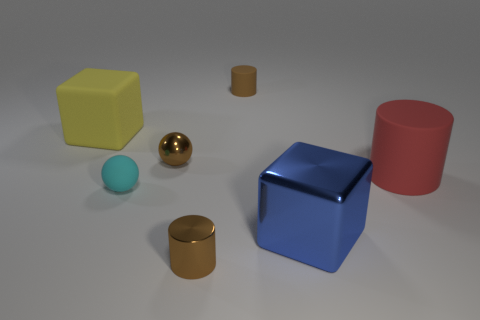Are there fewer red rubber cylinders to the left of the blue metallic thing than matte spheres that are left of the large red thing?
Give a very brief answer. Yes. How many big yellow blocks are there?
Your answer should be compact. 1. What material is the large red thing that is the same shape as the small brown rubber object?
Your answer should be very brief. Rubber. Is the number of red objects that are in front of the cyan thing less than the number of purple objects?
Provide a succinct answer. No. There is a matte thing that is behind the big yellow rubber cube; is it the same shape as the large yellow object?
Provide a short and direct response. No. Is there anything else that has the same color as the small rubber cylinder?
Ensure brevity in your answer.  Yes. There is a cube that is the same material as the big red cylinder; what is its size?
Offer a very short reply. Large. There is a tiny cylinder to the right of the brown shiny object that is to the right of the brown metal thing to the left of the brown shiny cylinder; what is it made of?
Your answer should be very brief. Rubber. Is the number of big blue things less than the number of purple things?
Give a very brief answer. No. Is the material of the large blue thing the same as the yellow cube?
Your answer should be very brief. No. 